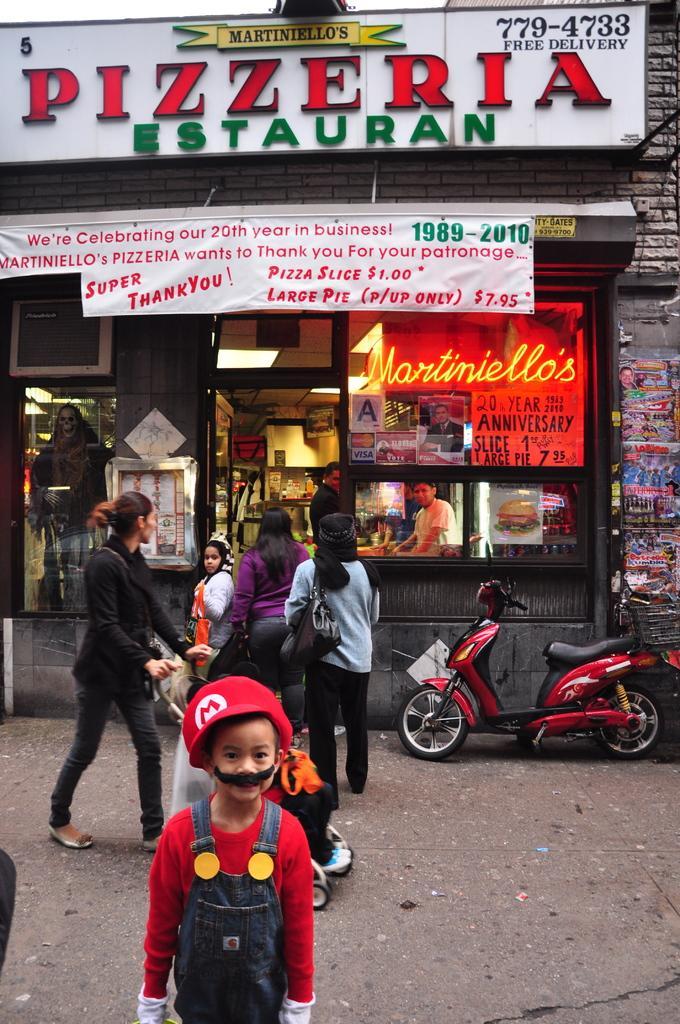Describe this image in one or two sentences. In the center of the image we can see three people are standing and wearing the bags and a lady is walking on the road and holding a trolley. At the bottom of the image we can see the road and a boy is standing and wearing a costume. In the background of the image we can see the source, boards, banner, lights, wall, mannequin, two people and motorcycle. At the top of the image we can see the sky. 